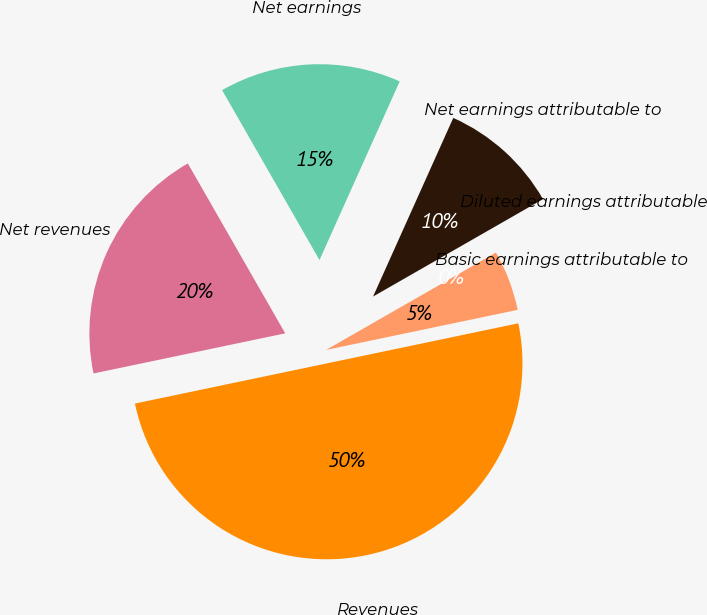Convert chart. <chart><loc_0><loc_0><loc_500><loc_500><pie_chart><fcel>Revenues<fcel>Net revenues<fcel>Net earnings<fcel>Net earnings attributable to<fcel>Diluted earnings attributable<fcel>Basic earnings attributable to<nl><fcel>50.0%<fcel>20.0%<fcel>15.0%<fcel>10.0%<fcel>0.0%<fcel>5.0%<nl></chart> 